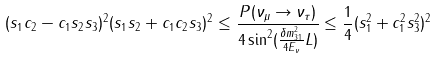Convert formula to latex. <formula><loc_0><loc_0><loc_500><loc_500>( s _ { 1 } c _ { 2 } - c _ { 1 } s _ { 2 } s _ { 3 } ) ^ { 2 } ( s _ { 1 } s _ { 2 } + c _ { 1 } c _ { 2 } s _ { 3 } ) ^ { 2 } \leq \frac { P ( \nu _ { \mu } \rightarrow \nu _ { \tau } ) } { 4 \sin ^ { 2 } ( \frac { \delta m _ { 3 1 } ^ { 2 } } { 4 E _ { \nu } } L ) } \leq \frac { 1 } { 4 } ( s _ { 1 } ^ { 2 } + c _ { 1 } ^ { 2 } s _ { 3 } ^ { 2 } ) ^ { 2 }</formula> 